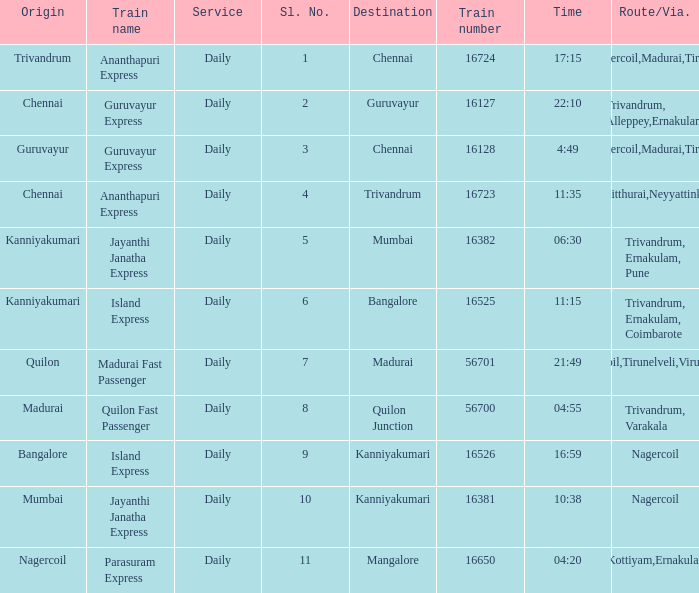What is the destination when the train number is 16526? Kanniyakumari. 